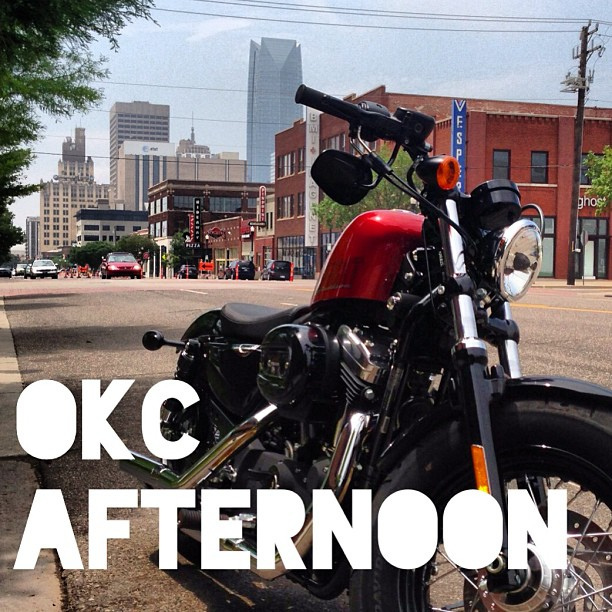<image>How much does the motorcycle cost? I don't know how much the motorcycle costs. The price could range from 3000 to 10000 dollars. How much does the motorcycle cost? I don't know how much the motorcycle costs. It can be anywhere from $1000 to $10000. 